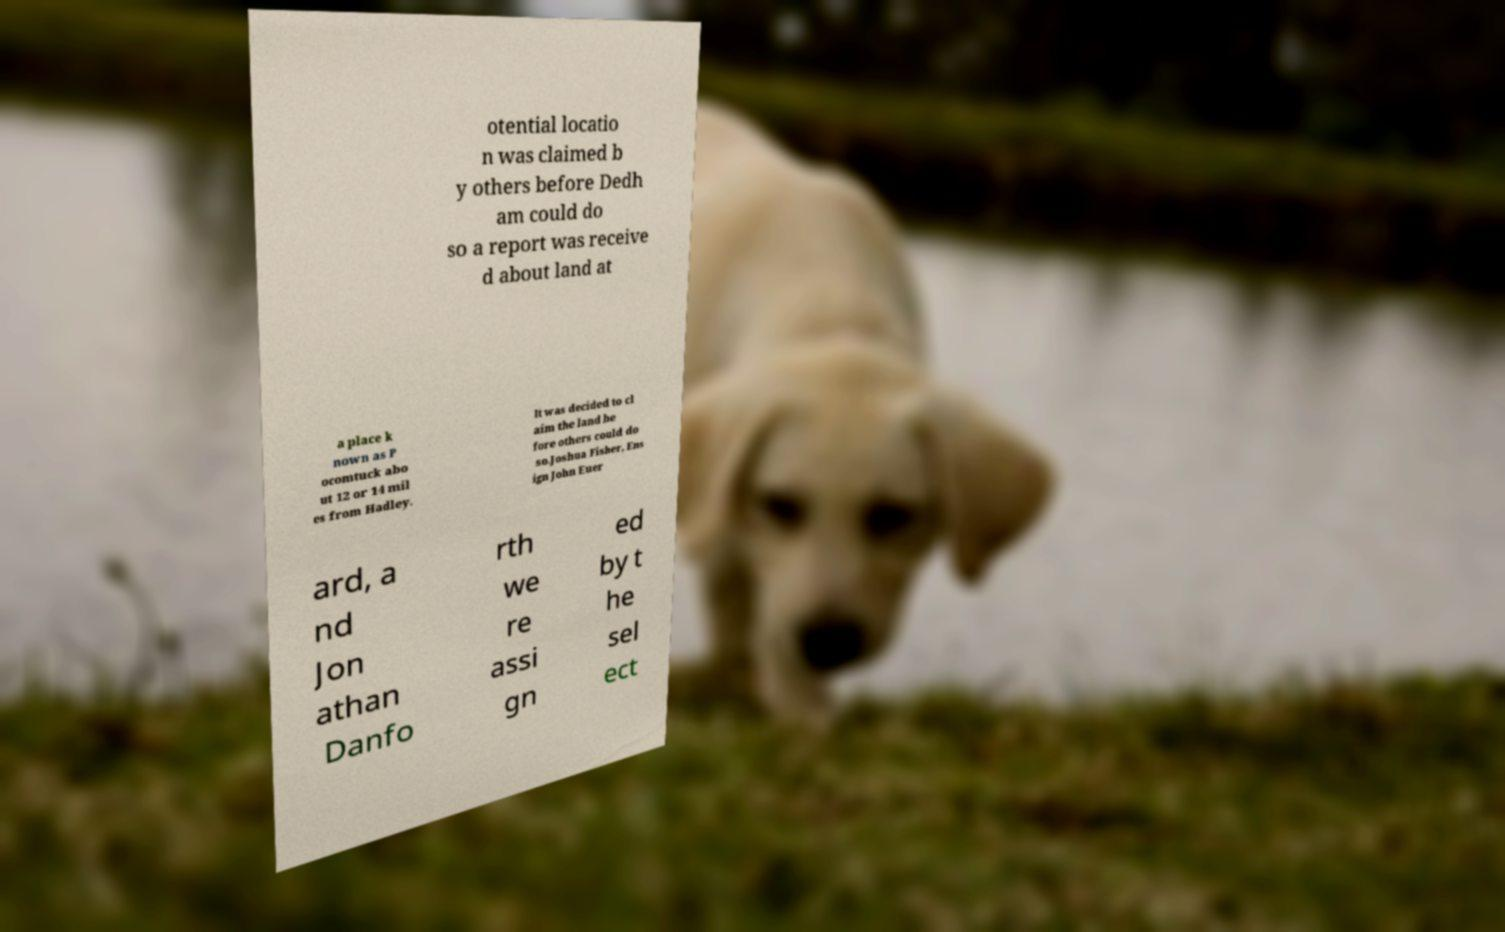Can you read and provide the text displayed in the image?This photo seems to have some interesting text. Can you extract and type it out for me? otential locatio n was claimed b y others before Dedh am could do so a report was receive d about land at a place k nown as P ocomtuck abo ut 12 or 14 mil es from Hadley. It was decided to cl aim the land be fore others could do so.Joshua Fisher, Ens ign John Euer ard, a nd Jon athan Danfo rth we re assi gn ed by t he sel ect 